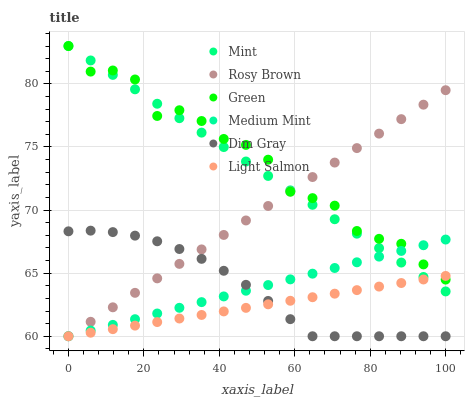Does Light Salmon have the minimum area under the curve?
Answer yes or no. Yes. Does Green have the maximum area under the curve?
Answer yes or no. Yes. Does Dim Gray have the minimum area under the curve?
Answer yes or no. No. Does Dim Gray have the maximum area under the curve?
Answer yes or no. No. Is Medium Mint the smoothest?
Answer yes or no. Yes. Is Green the roughest?
Answer yes or no. Yes. Is Light Salmon the smoothest?
Answer yes or no. No. Is Light Salmon the roughest?
Answer yes or no. No. Does Medium Mint have the lowest value?
Answer yes or no. Yes. Does Green have the lowest value?
Answer yes or no. No. Does Mint have the highest value?
Answer yes or no. Yes. Does Dim Gray have the highest value?
Answer yes or no. No. Is Dim Gray less than Mint?
Answer yes or no. Yes. Is Mint greater than Dim Gray?
Answer yes or no. Yes. Does Rosy Brown intersect Mint?
Answer yes or no. Yes. Is Rosy Brown less than Mint?
Answer yes or no. No. Is Rosy Brown greater than Mint?
Answer yes or no. No. Does Dim Gray intersect Mint?
Answer yes or no. No. 